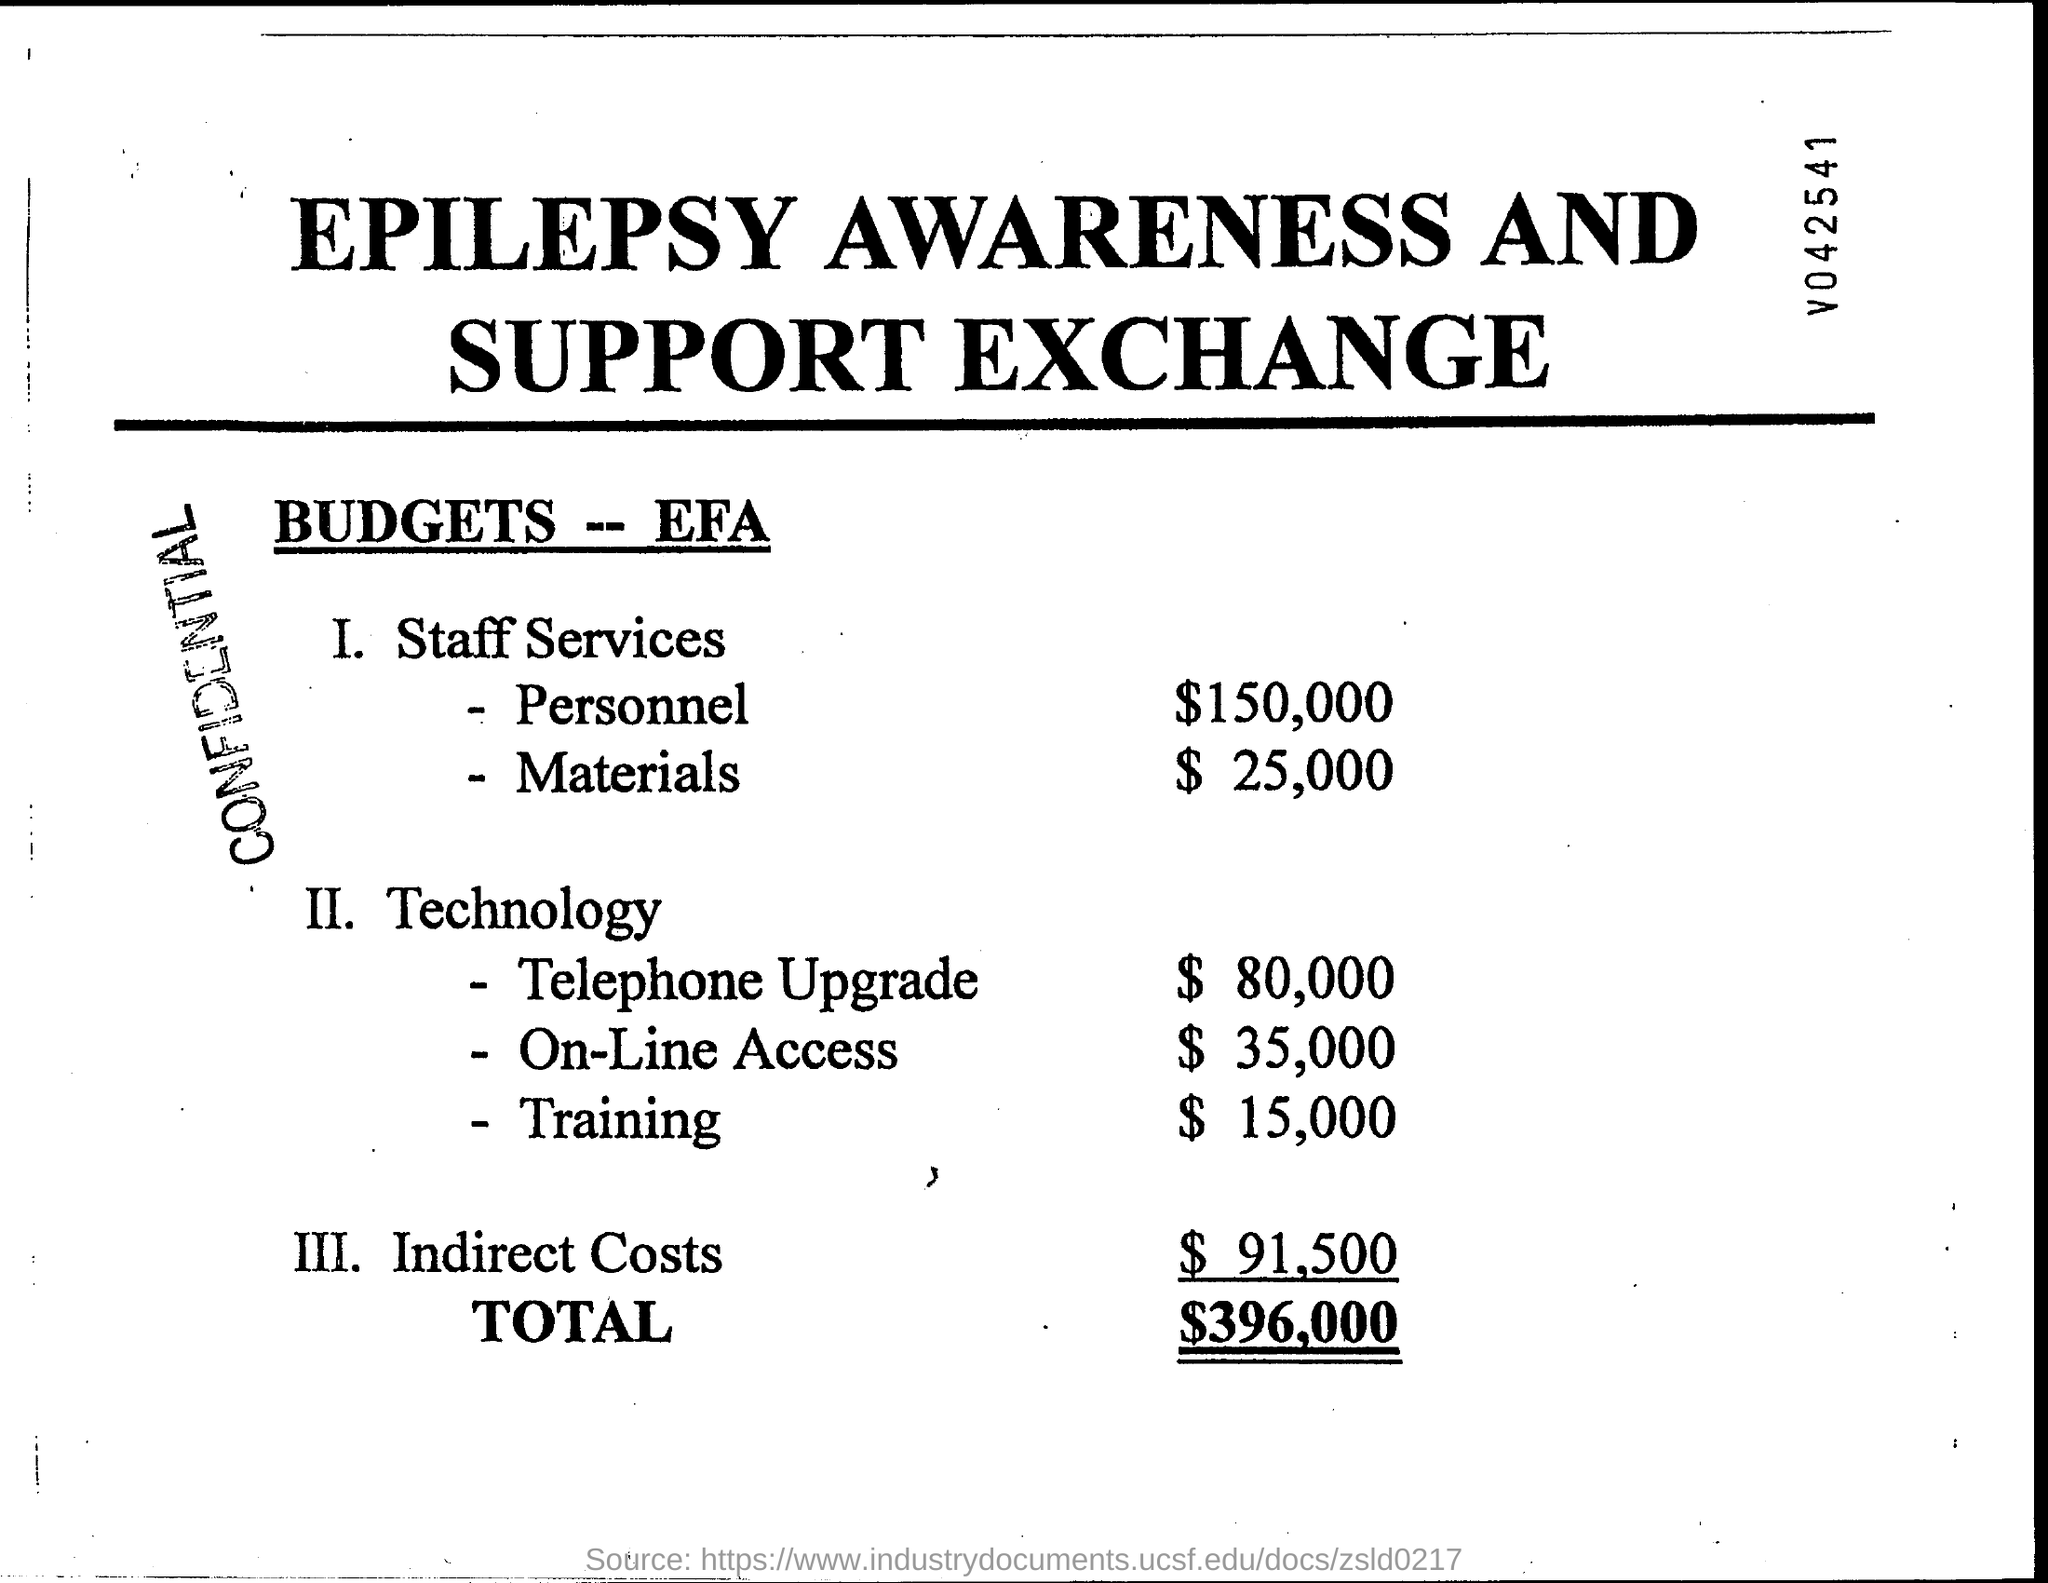What is the stamp on the document?
Offer a terse response. CONFIDENTIAL. 